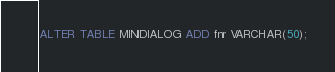Convert code to text. <code><loc_0><loc_0><loc_500><loc_500><_SQL_>ALTER TABLE MINIDIALOG ADD fnr VARCHAR(50);
</code> 